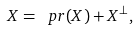<formula> <loc_0><loc_0><loc_500><loc_500>X = \ p r ( X ) + X ^ { \bot } ,</formula> 